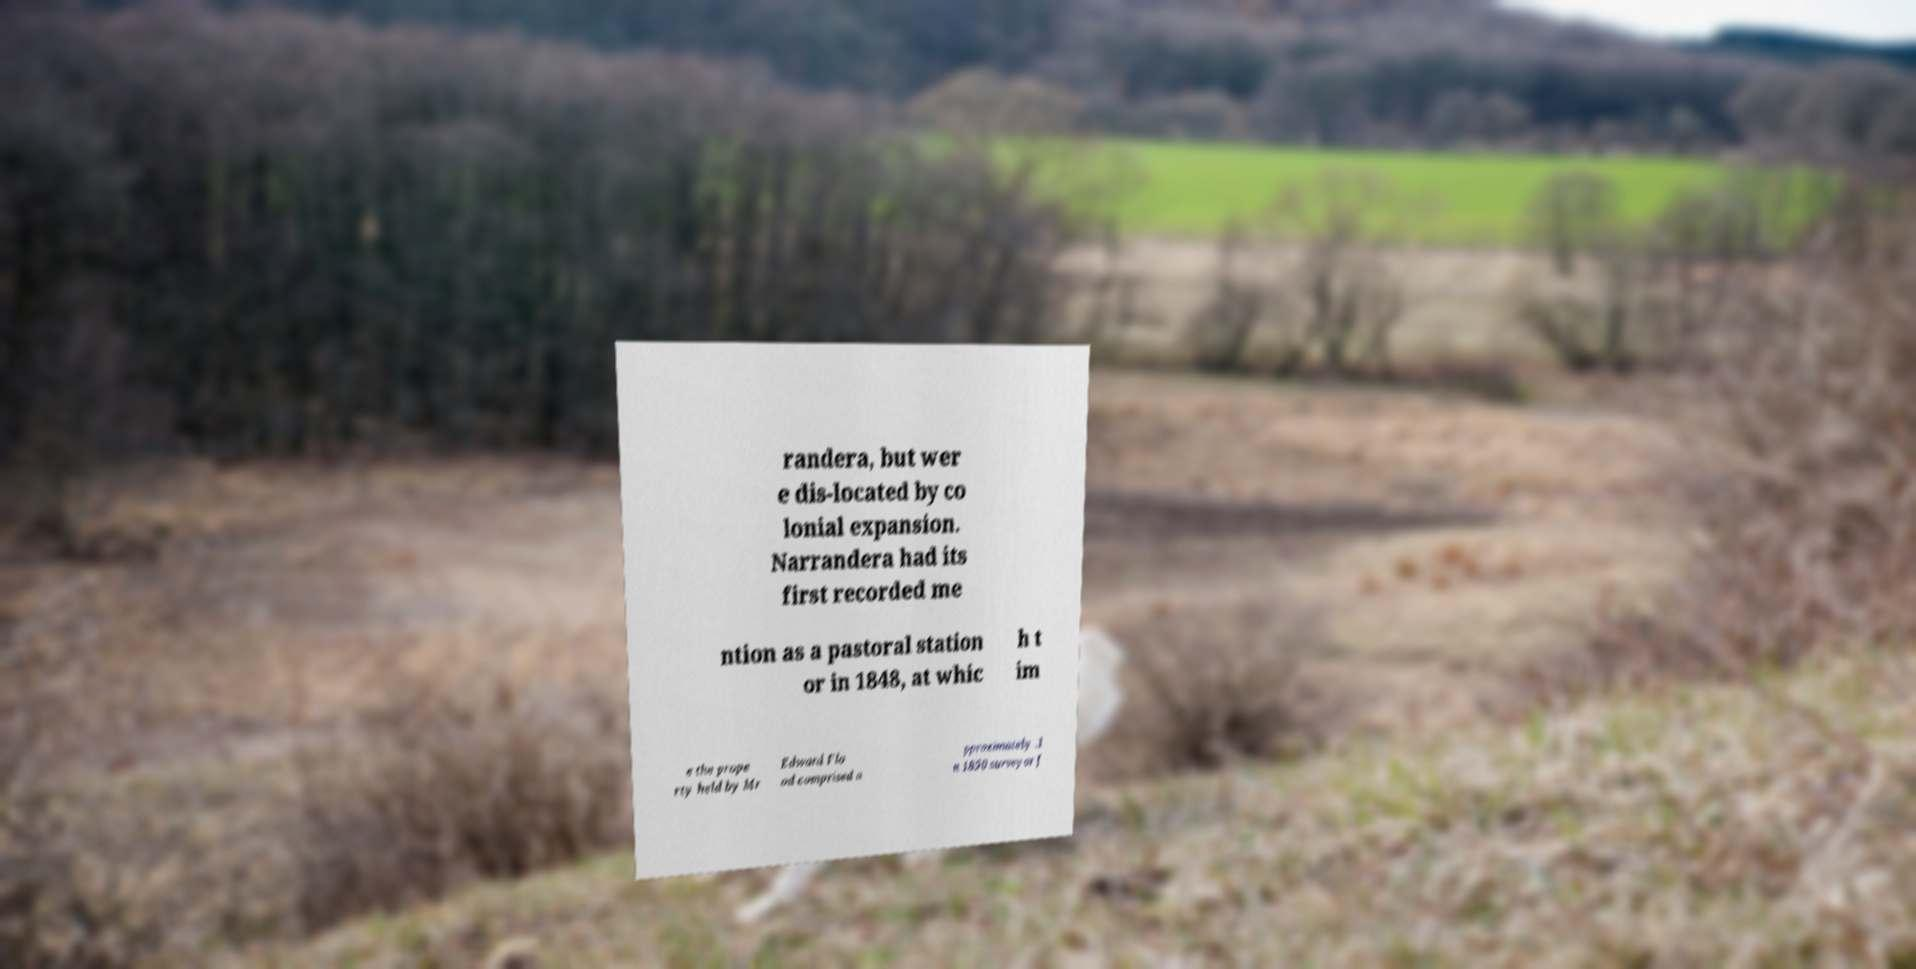Can you accurately transcribe the text from the provided image for me? randera, but wer e dis-located by co lonial expansion. Narrandera had its first recorded me ntion as a pastoral station or in 1848, at whic h t im e the prope rty held by Mr Edward Flo od comprised a pproximately .I n 1850 surveyor J 